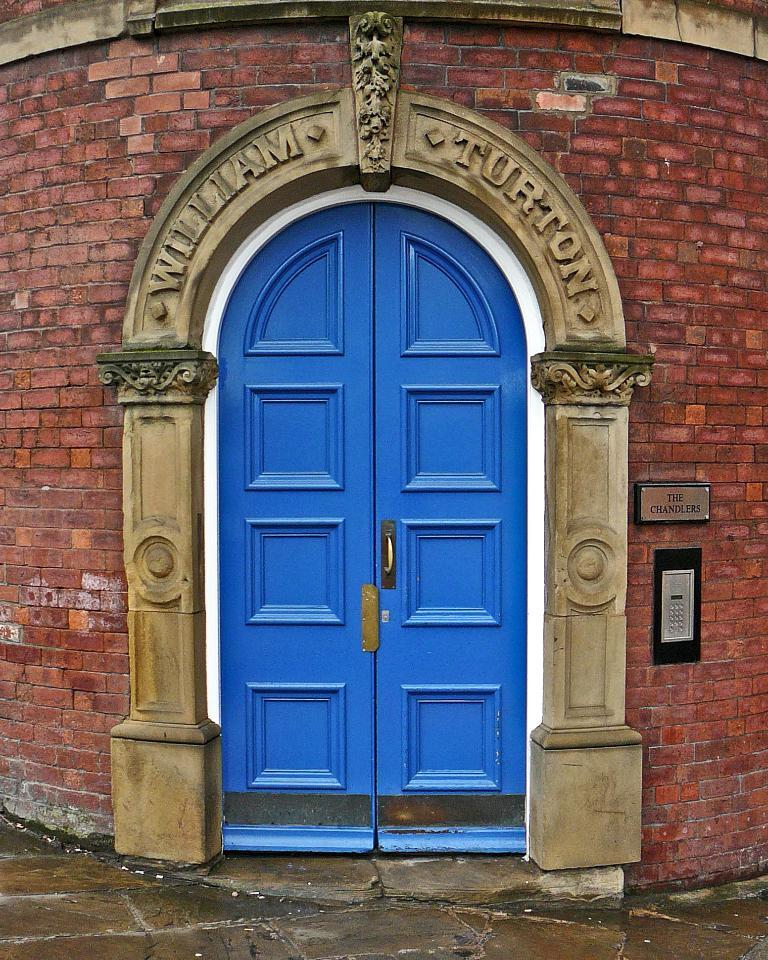What type of structure is present in the image? There is a building in the image. What can be seen on the building? There is a board with text on the building, and there is another object on the building. What color are the doors visible in the image? The doors visible in the image are blue. How many horses can be seen grazing in the field next to the building in the image? There are no horses or fields visible in the image; it only features a building with a board, another object, and blue doors. 